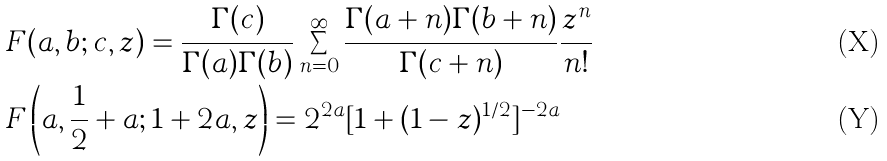Convert formula to latex. <formula><loc_0><loc_0><loc_500><loc_500>& F ( a , b ; c , z ) = \frac { \Gamma ( c ) } { \Gamma ( a ) \Gamma ( b ) } \sum ^ { \infty } _ { n = 0 } \frac { \Gamma ( a + n ) \Gamma ( b + n ) } { \Gamma ( c + n ) } \frac { z ^ { n } } { n ! } \\ & F \left ( a , \frac { 1 } { 2 } + a ; 1 + 2 a , z \right ) = 2 ^ { 2 a } [ 1 + ( 1 - z ) ^ { 1 / 2 } ] ^ { - 2 a }</formula> 